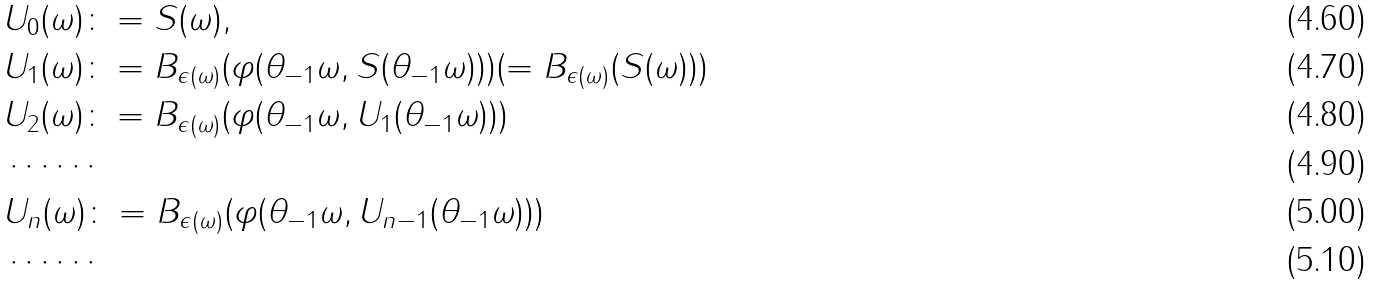<formula> <loc_0><loc_0><loc_500><loc_500>& U _ { 0 } ( \omega ) \colon = S ( \omega ) , \\ & U _ { 1 } ( \omega ) \colon = B _ { \epsilon ( \omega ) } ( \varphi ( \theta _ { - 1 } \omega , S ( \theta _ { - 1 } \omega ) ) ) ( = B _ { \epsilon ( \omega ) } ( S ( \omega ) ) ) \\ & U _ { 2 } ( \omega ) \colon = B _ { \epsilon ( \omega ) } ( \varphi ( \theta _ { - 1 } \omega , U _ { 1 } ( \theta _ { - 1 } \omega ) ) ) \\ & \cdots \cdots \\ & U _ { n } ( \omega ) \colon = B _ { \epsilon ( \omega ) } ( \varphi ( \theta _ { - 1 } \omega , U _ { n - 1 } ( \theta _ { - 1 } \omega ) ) ) \\ & \cdots \cdots</formula> 